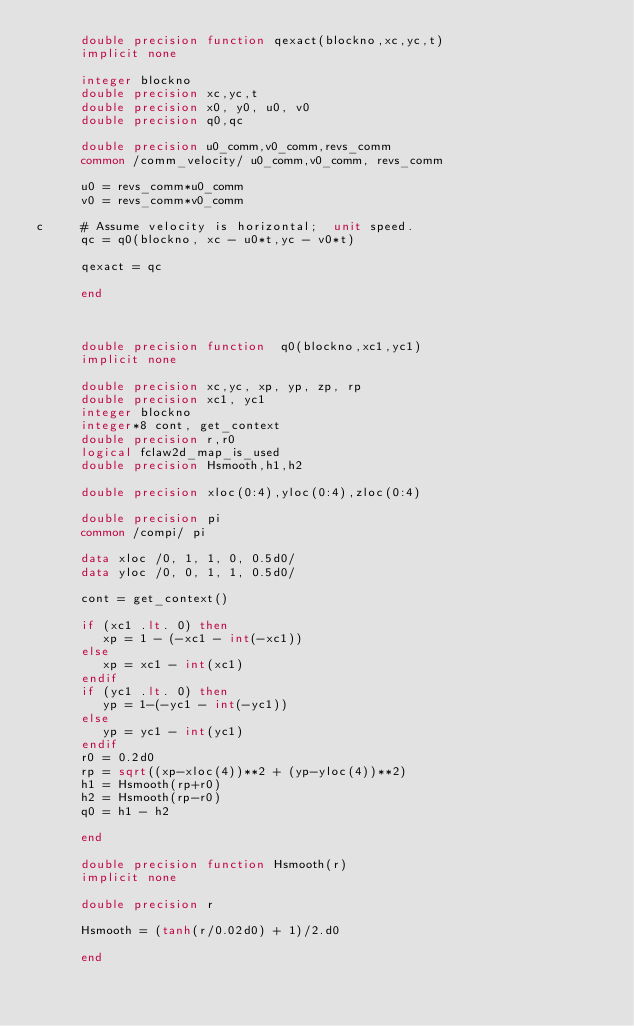Convert code to text. <code><loc_0><loc_0><loc_500><loc_500><_FORTRAN_>      double precision function qexact(blockno,xc,yc,t)
      implicit none

      integer blockno
      double precision xc,yc,t
      double precision x0, y0, u0, v0
      double precision q0,qc

      double precision u0_comm,v0_comm,revs_comm
      common /comm_velocity/ u0_comm,v0_comm, revs_comm

      u0 = revs_comm*u0_comm
      v0 = revs_comm*v0_comm

c     # Assume velocity is horizontal;  unit speed.
      qc = q0(blockno, xc - u0*t,yc - v0*t)

      qexact = qc

      end



      double precision function  q0(blockno,xc1,yc1)
      implicit none

      double precision xc,yc, xp, yp, zp, rp
      double precision xc1, yc1
      integer blockno
      integer*8 cont, get_context
      double precision r,r0
      logical fclaw2d_map_is_used
      double precision Hsmooth,h1,h2

      double precision xloc(0:4),yloc(0:4),zloc(0:4)

      double precision pi
      common /compi/ pi

      data xloc /0, 1, 1, 0, 0.5d0/
      data yloc /0, 0, 1, 1, 0.5d0/

      cont = get_context()

      if (xc1 .lt. 0) then
         xp = 1 - (-xc1 - int(-xc1))
      else
         xp = xc1 - int(xc1)
      endif
      if (yc1 .lt. 0) then
         yp = 1-(-yc1 - int(-yc1))
      else
         yp = yc1 - int(yc1)
      endif
      r0 = 0.2d0
      rp = sqrt((xp-xloc(4))**2 + (yp-yloc(4))**2)
      h1 = Hsmooth(rp+r0)
      h2 = Hsmooth(rp-r0)
      q0 = h1 - h2

      end

      double precision function Hsmooth(r)
      implicit none

      double precision r

      Hsmooth = (tanh(r/0.02d0) + 1)/2.d0

      end
</code> 